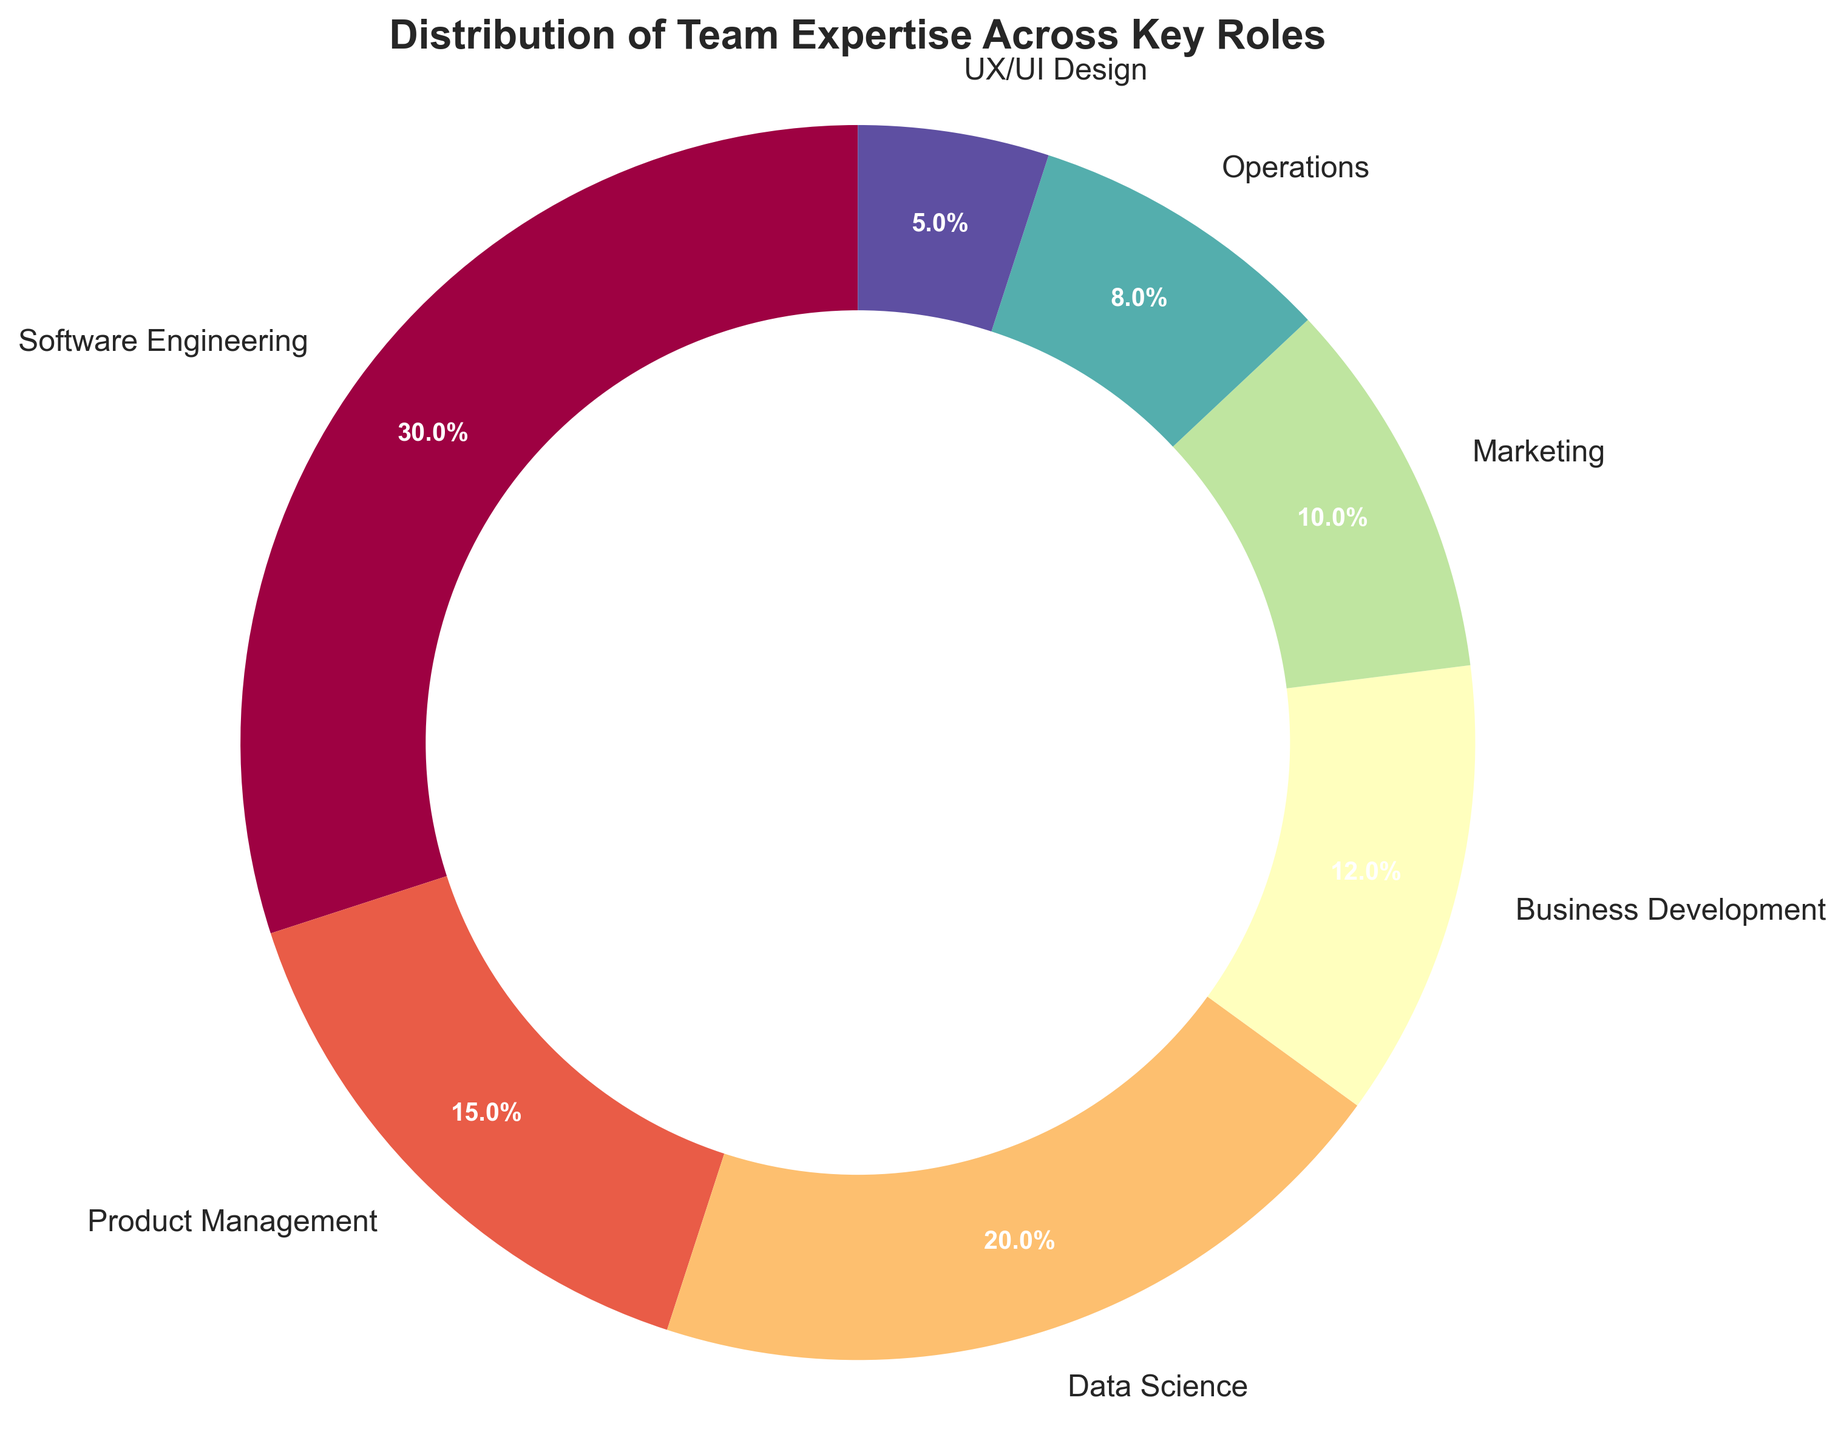What role has the largest percentage of team expertise? The pie chart shows the distribution of team expertise across different roles, with "Software Engineering" having the largest percentage, which is 30%.
Answer: Software Engineering What is the combined percentage of expertise in Product Management and Data Science roles? The percentage of expertise in Product Management is 15%, and in Data Science is 20%. Adding these together, 15% + 20% = 35%.
Answer: 35% How much larger is the percentage of team expertise in Software Engineering compared to Marketing? The percentage of expertise in Software Engineering is 30%, and in Marketing is 10%. The difference is 30% - 10% = 20%.
Answer: 20% Which role has the smallest percentage of team expertise? The pie chart shows different roles with percentages, and "UX/UI Design" has the smallest percentage, which is 5%.
Answer: UX/UI Design What is the approximate central color of the wedge representing Data Science? In the pie chart, Data Science is represented by a wedge. The approximate central color of this wedge appears to be in the middle of the color spectrum used, likely a greenish-yellow hue in this specific color scheme.
Answer: Greenish-yellow How does the percentage of team expertise in Business Development compare to Operations? The percentage of team expertise in Business Development is 12% and in Operations is 8%. Comparing these, Business Development has a higher percentage.
Answer: Business Development What is the total percentage of expertise for roles under 10% each? The roles with under 10% each are Marketing (10%), Operations (8%), and UX/UI Design (5%). Summing them up, 10% + 8% + 5% = 23%.
Answer: 23% What percentage more expertise is in Software Engineering than in Data Science? The percentage of expertise in Software Engineering is 30% and in Data Science is 20%. Thus, there is 30% - 20% = 10% more expertise in Software Engineering than in Data Science.
Answer: 10% Out of all roles, which three have the highest percentage of team expertise combined? Sorting the roles by percentage, the top three are Software Engineering (30%), Data Science (20%), and Product Management (15%). Combining these, 30% + 20% + 15% = 65%.
Answer: 65% What portion of the team expertise is outside the core technical roles of Software Engineering and Data Science? Software Engineering accounts for 30% and Data Science 20%, so core technical roles sum up to 50%. The total percentage outside these roles is 100% - 50% = 50%.
Answer: 50% 